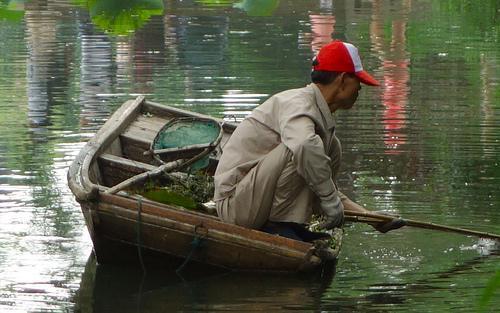How many people are in the picture?
Give a very brief answer. 1. How many people are wearing hat?
Give a very brief answer. 1. 